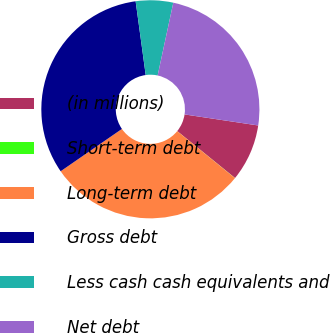<chart> <loc_0><loc_0><loc_500><loc_500><pie_chart><fcel>(in millions)<fcel>Short-term debt<fcel>Long-term debt<fcel>Gross debt<fcel>Less cash cash equivalents and<fcel>Net debt<nl><fcel>8.48%<fcel>0.02%<fcel>29.51%<fcel>32.46%<fcel>5.53%<fcel>24.0%<nl></chart> 